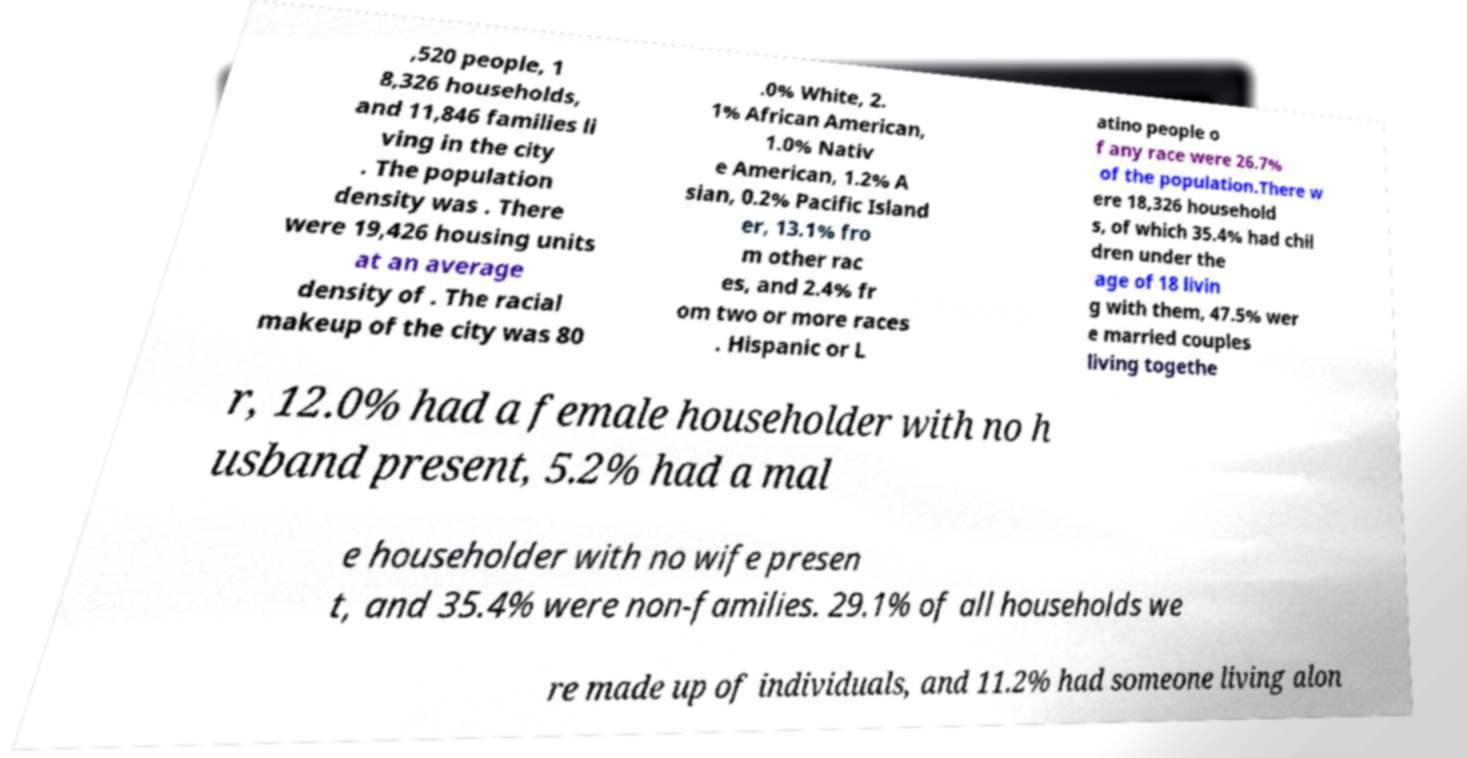For documentation purposes, I need the text within this image transcribed. Could you provide that? ,520 people, 1 8,326 households, and 11,846 families li ving in the city . The population density was . There were 19,426 housing units at an average density of . The racial makeup of the city was 80 .0% White, 2. 1% African American, 1.0% Nativ e American, 1.2% A sian, 0.2% Pacific Island er, 13.1% fro m other rac es, and 2.4% fr om two or more races . Hispanic or L atino people o f any race were 26.7% of the population.There w ere 18,326 household s, of which 35.4% had chil dren under the age of 18 livin g with them, 47.5% wer e married couples living togethe r, 12.0% had a female householder with no h usband present, 5.2% had a mal e householder with no wife presen t, and 35.4% were non-families. 29.1% of all households we re made up of individuals, and 11.2% had someone living alon 